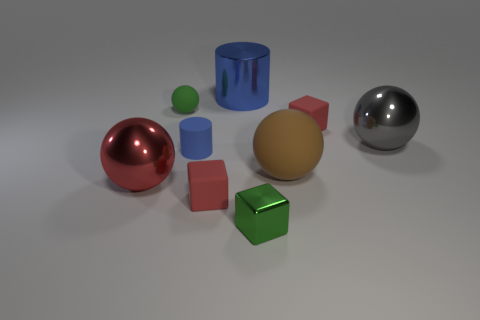There is a tiny red thing right of the tiny rubber cube that is in front of the shiny thing that is on the left side of the small green sphere; what is its material?
Ensure brevity in your answer.  Rubber. Are there any big metallic cylinders that have the same color as the matte cylinder?
Make the answer very short. Yes. Are there fewer large objects in front of the red sphere than large red cubes?
Your response must be concise. No. Do the red object that is on the right side of the brown thing and the blue metal thing have the same size?
Give a very brief answer. No. What number of matte things are right of the large blue shiny thing and to the left of the blue metallic cylinder?
Provide a succinct answer. 0. There is a shiny thing in front of the red rubber cube that is on the left side of the large blue cylinder; what is its size?
Make the answer very short. Small. Is the number of red metal things that are behind the red shiny sphere less than the number of tiny blue cylinders that are in front of the brown rubber sphere?
Offer a terse response. No. There is a large shiny thing that is in front of the brown matte ball; is its color the same as the matte ball to the left of the large shiny cylinder?
Give a very brief answer. No. What is the sphere that is left of the blue metallic cylinder and behind the brown object made of?
Your answer should be compact. Rubber. Are any large yellow cylinders visible?
Keep it short and to the point. No. 